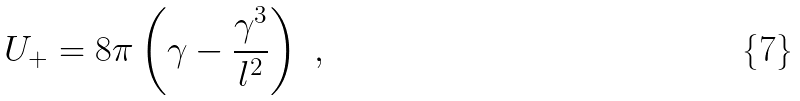<formula> <loc_0><loc_0><loc_500><loc_500>U _ { + } = 8 \pi \left ( \gamma - \frac { \gamma ^ { 3 } } { l ^ { 2 } } \right ) \ ,</formula> 